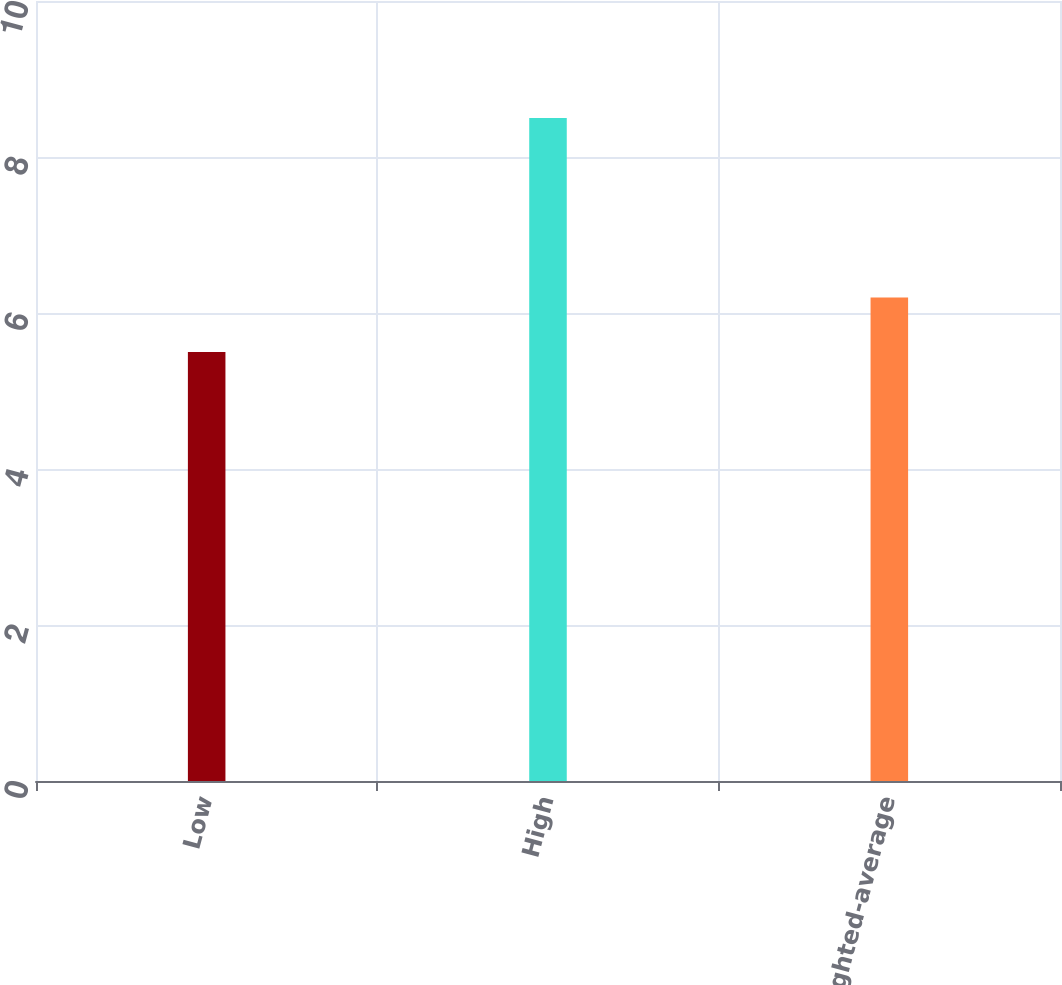<chart> <loc_0><loc_0><loc_500><loc_500><bar_chart><fcel>Low<fcel>High<fcel>Weighted-average<nl><fcel>5.5<fcel>8.5<fcel>6.2<nl></chart> 